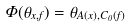Convert formula to latex. <formula><loc_0><loc_0><loc_500><loc_500>\Phi ( \theta _ { x , f } ) = \theta _ { A ( x ) , C _ { 0 } ( f ) }</formula> 